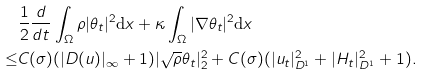Convert formula to latex. <formula><loc_0><loc_0><loc_500><loc_500>& \frac { 1 } { 2 } \frac { d } { d t } \int _ { \Omega } \rho | \theta _ { t } | ^ { 2 } \text {d} x + \kappa \int _ { \Omega } | \nabla \theta _ { t } | ^ { 2 } \text {d} x \\ \leq & C ( \sigma ) ( | D ( u ) | _ { \infty } + 1 ) | \sqrt { \rho } \theta _ { t } | ^ { 2 } _ { 2 } + C ( \sigma ) ( | u _ { t } | ^ { 2 } _ { D ^ { 1 } } + | H _ { t } | ^ { 2 } _ { D ^ { 1 } } + 1 ) .</formula> 